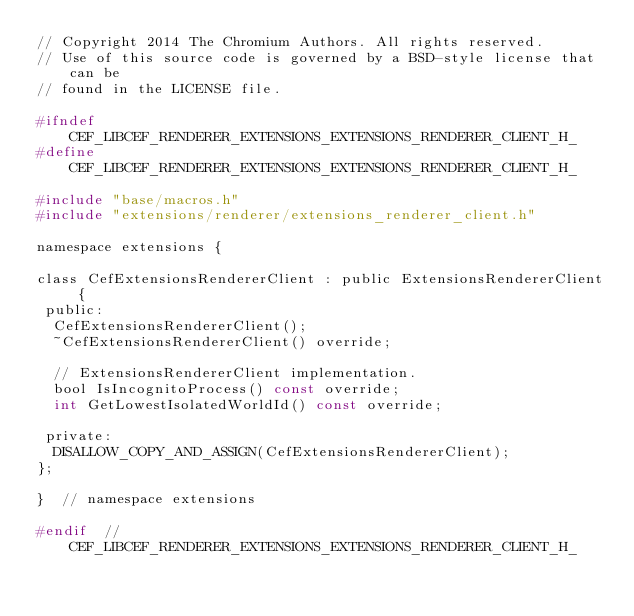<code> <loc_0><loc_0><loc_500><loc_500><_C_>// Copyright 2014 The Chromium Authors. All rights reserved.
// Use of this source code is governed by a BSD-style license that can be
// found in the LICENSE file.

#ifndef CEF_LIBCEF_RENDERER_EXTENSIONS_EXTENSIONS_RENDERER_CLIENT_H_
#define CEF_LIBCEF_RENDERER_EXTENSIONS_EXTENSIONS_RENDERER_CLIENT_H_

#include "base/macros.h"
#include "extensions/renderer/extensions_renderer_client.h"

namespace extensions {

class CefExtensionsRendererClient : public ExtensionsRendererClient {
 public:
  CefExtensionsRendererClient();
  ~CefExtensionsRendererClient() override;

  // ExtensionsRendererClient implementation.
  bool IsIncognitoProcess() const override;
  int GetLowestIsolatedWorldId() const override;

 private:
  DISALLOW_COPY_AND_ASSIGN(CefExtensionsRendererClient);
};

}  // namespace extensions

#endif  // CEF_LIBCEF_RENDERER_EXTENSIONS_EXTENSIONS_RENDERER_CLIENT_H_
</code> 